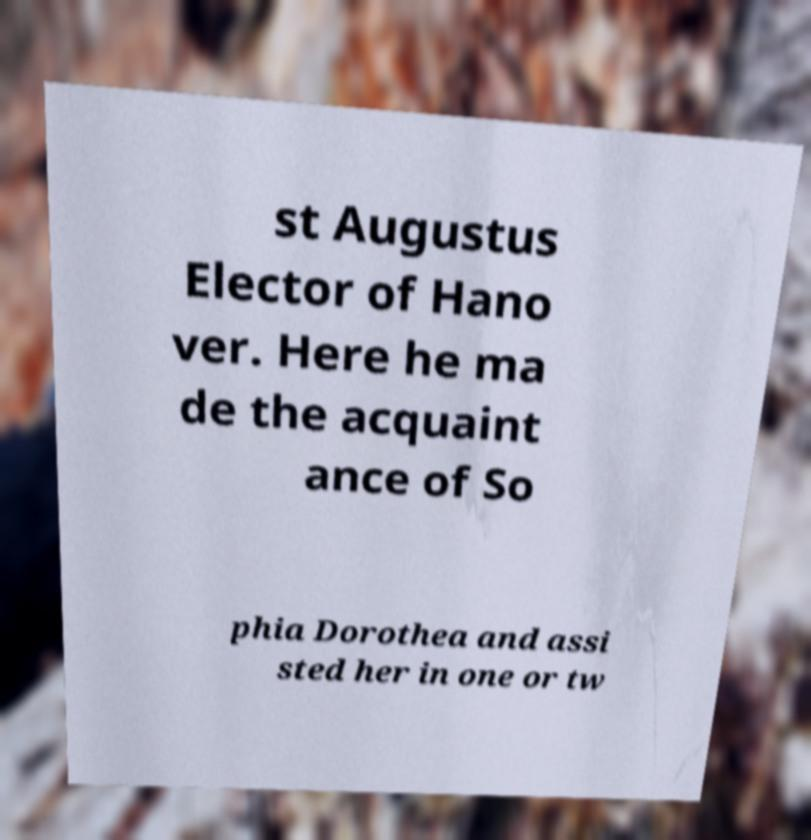Could you assist in decoding the text presented in this image and type it out clearly? st Augustus Elector of Hano ver. Here he ma de the acquaint ance of So phia Dorothea and assi sted her in one or tw 